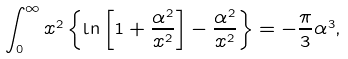<formula> <loc_0><loc_0><loc_500><loc_500>\int _ { 0 } ^ { \infty } x ^ { 2 } \left \{ \ln \left [ 1 + \frac { \alpha ^ { 2 } } { x ^ { 2 } } \right ] - \frac { \alpha ^ { 2 } } { x ^ { 2 } } \right \} = - \frac { \pi } { 3 } \alpha ^ { 3 } ,</formula> 